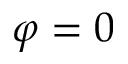Convert formula to latex. <formula><loc_0><loc_0><loc_500><loc_500>\varphi = 0</formula> 